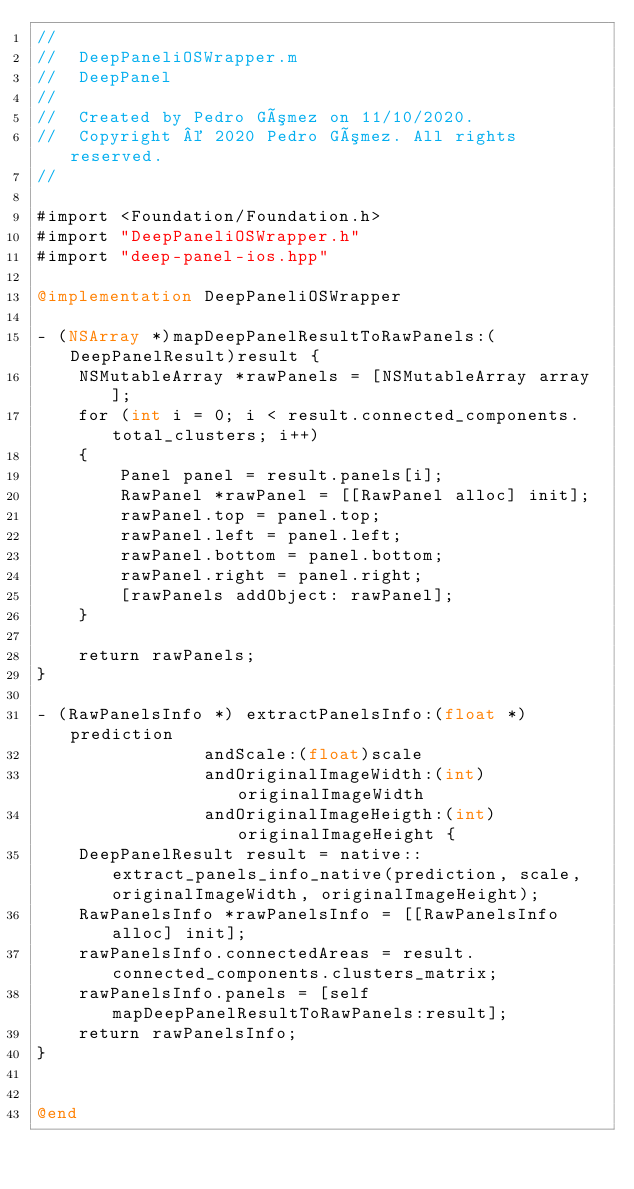<code> <loc_0><loc_0><loc_500><loc_500><_ObjectiveC_>//
//  DeepPaneliOSWrapper.m
//  DeepPanel
//
//  Created by Pedro Gómez on 11/10/2020.
//  Copyright © 2020 Pedro Gómez. All rights reserved.
//

#import <Foundation/Foundation.h>
#import "DeepPaneliOSWrapper.h"
#import "deep-panel-ios.hpp"

@implementation DeepPaneliOSWrapper

- (NSArray *)mapDeepPanelResultToRawPanels:(DeepPanelResult)result {
    NSMutableArray *rawPanels = [NSMutableArray array];
    for (int i = 0; i < result.connected_components.total_clusters; i++)
    {
        Panel panel = result.panels[i];
        RawPanel *rawPanel = [[RawPanel alloc] init];
        rawPanel.top = panel.top;
        rawPanel.left = panel.left;
        rawPanel.bottom = panel.bottom;
        rawPanel.right = panel.right;
        [rawPanels addObject: rawPanel];
    }
    
    return rawPanels;
}

- (RawPanelsInfo *) extractPanelsInfo:(float *)prediction
                andScale:(float)scale
                andOriginalImageWidth:(int)originalImageWidth
                andOriginalImageHeigth:(int)originalImageHeight {
    DeepPanelResult result = native::extract_panels_info_native(prediction, scale, originalImageWidth, originalImageHeight);
    RawPanelsInfo *rawPanelsInfo = [[RawPanelsInfo alloc] init];
    rawPanelsInfo.connectedAreas = result.connected_components.clusters_matrix;
    rawPanelsInfo.panels = [self mapDeepPanelResultToRawPanels:result];
    return rawPanelsInfo;
}


@end
</code> 